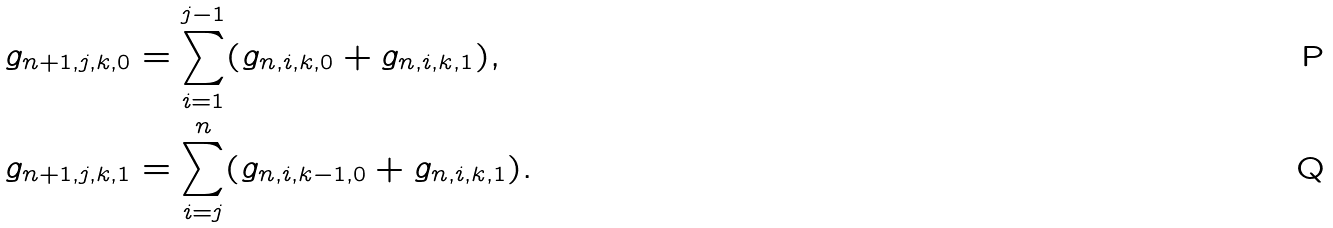<formula> <loc_0><loc_0><loc_500><loc_500>g _ { n + 1 , j , k , 0 } & = \sum _ { i = 1 } ^ { j - 1 } ( g _ { n , i , k , 0 } + g _ { n , i , k , 1 } ) , \\ g _ { n + 1 , j , k , 1 } & = \sum _ { i = j } ^ { n } ( g _ { n , i , k - 1 , 0 } + g _ { n , i , k , 1 } ) .</formula> 